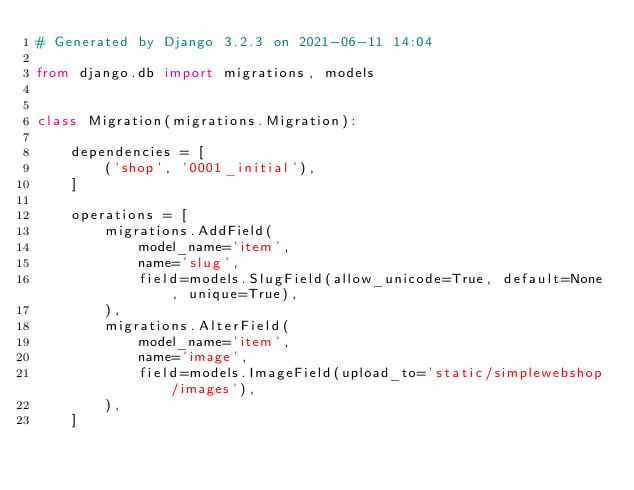Convert code to text. <code><loc_0><loc_0><loc_500><loc_500><_Python_># Generated by Django 3.2.3 on 2021-06-11 14:04

from django.db import migrations, models


class Migration(migrations.Migration):

    dependencies = [
        ('shop', '0001_initial'),
    ]

    operations = [
        migrations.AddField(
            model_name='item',
            name='slug',
            field=models.SlugField(allow_unicode=True, default=None, unique=True),
        ),
        migrations.AlterField(
            model_name='item',
            name='image',
            field=models.ImageField(upload_to='static/simplewebshop/images'),
        ),
    ]
</code> 